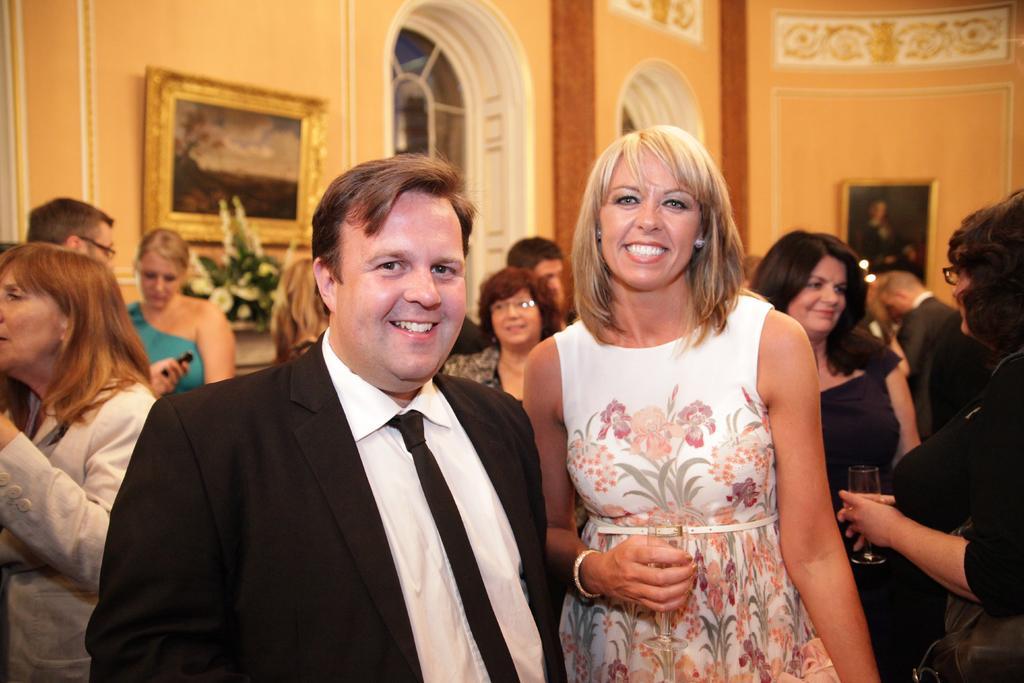How would you summarize this image in a sentence or two? In this image we can see persons standing on the floor. In the background we can see wall hangings, windows, walls and flowers. 